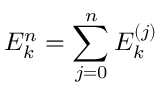Convert formula to latex. <formula><loc_0><loc_0><loc_500><loc_500>E _ { k } ^ { n } = \sum _ { j = 0 } ^ { n } E _ { k } ^ { ( j ) }</formula> 